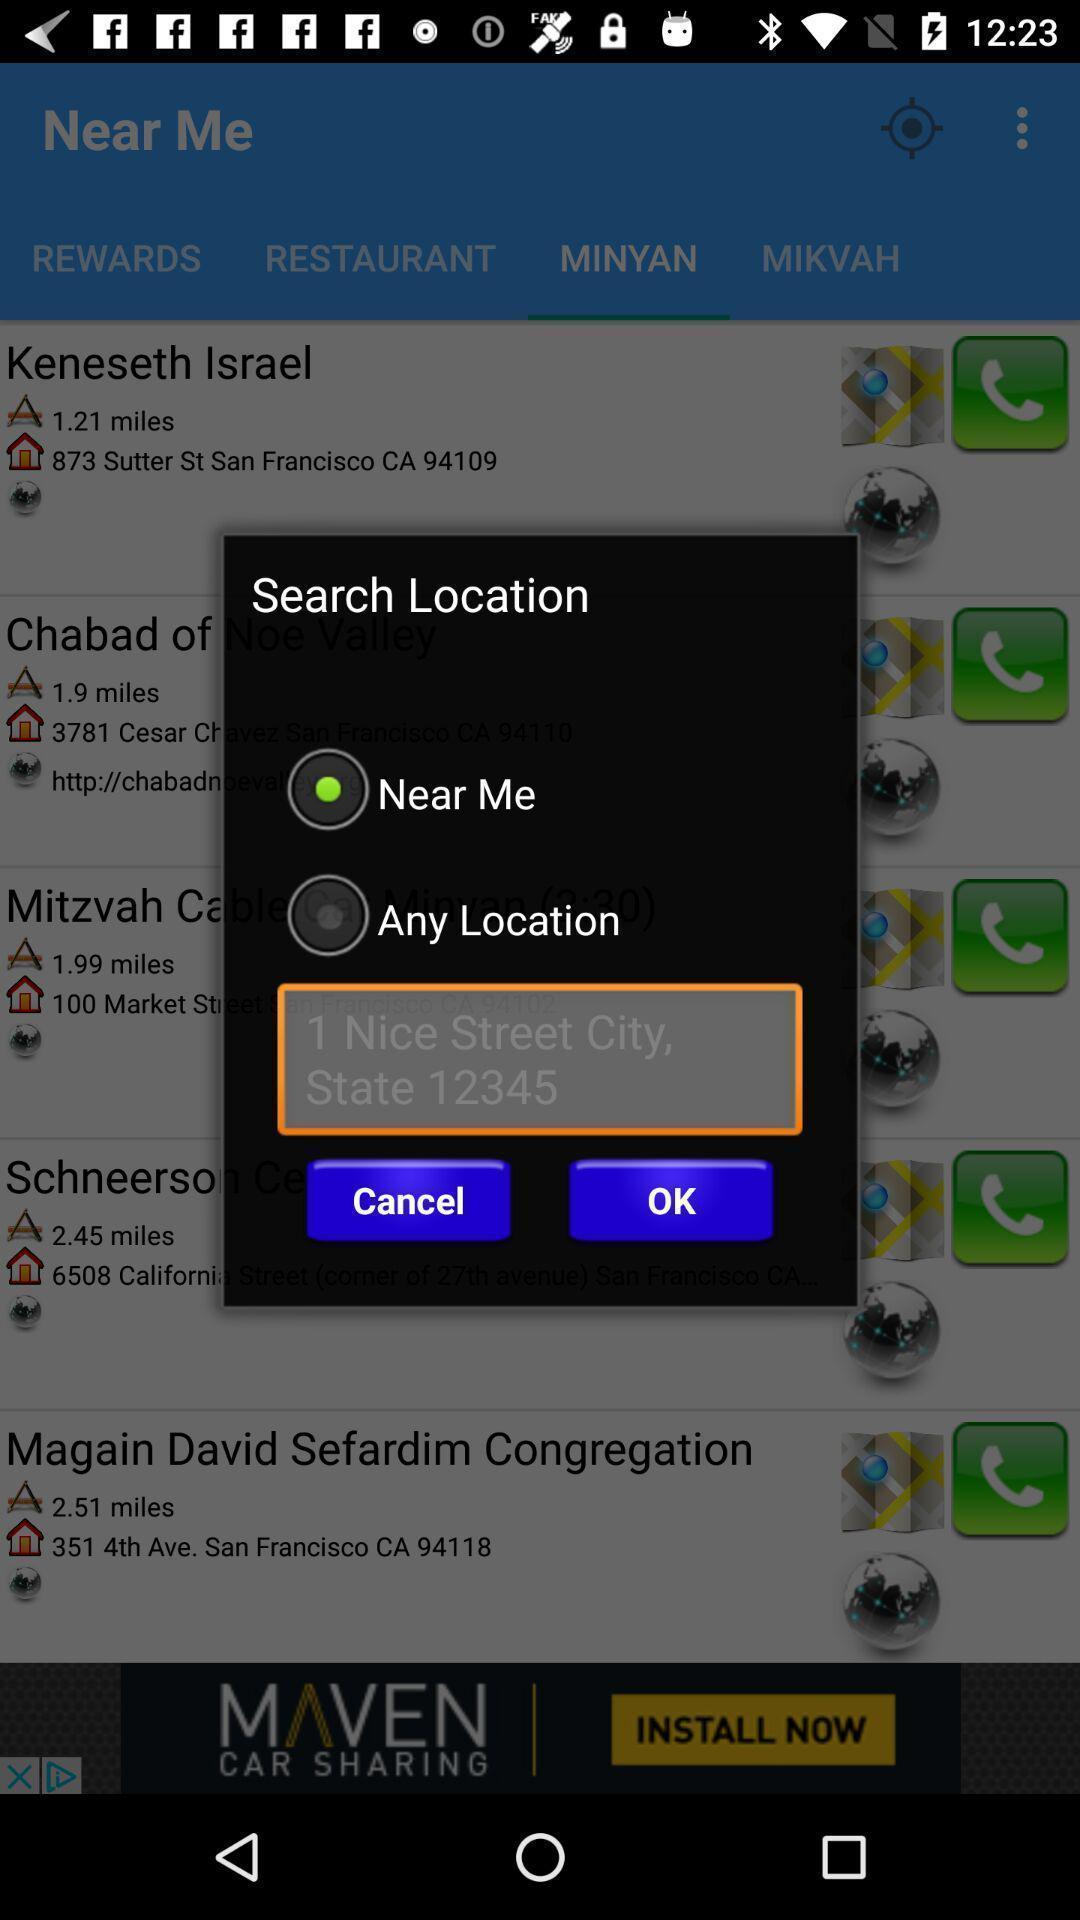Describe this image in words. Pop-up showing the multiple options about location. 